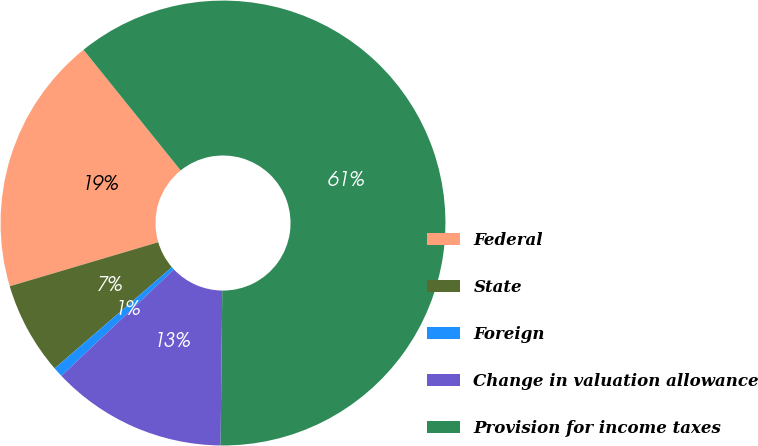Convert chart. <chart><loc_0><loc_0><loc_500><loc_500><pie_chart><fcel>Federal<fcel>State<fcel>Foreign<fcel>Change in valuation allowance<fcel>Provision for income taxes<nl><fcel>18.8%<fcel>6.75%<fcel>0.72%<fcel>12.77%<fcel>60.97%<nl></chart> 